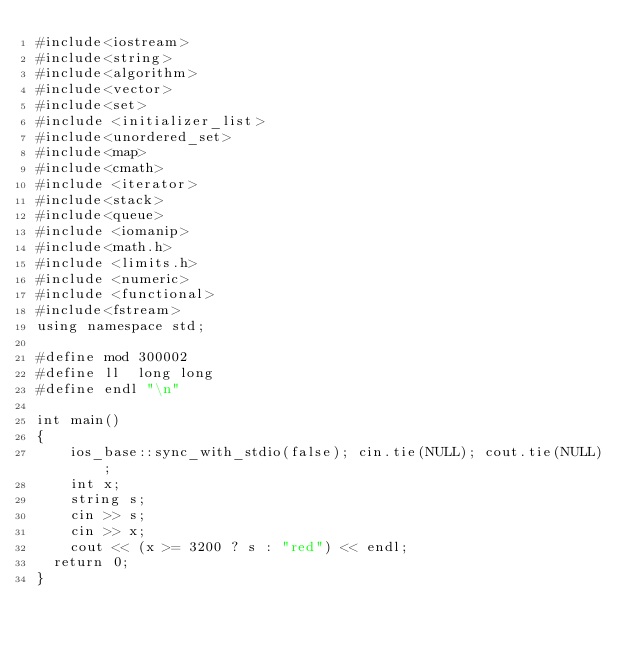Convert code to text. <code><loc_0><loc_0><loc_500><loc_500><_C++_>#include<iostream>
#include<string>
#include<algorithm>
#include<vector>
#include<set>
#include <initializer_list>
#include<unordered_set>
#include<map>
#include<cmath>
#include <iterator>
#include<stack>
#include<queue>
#include <iomanip>
#include<math.h>
#include <limits.h>
#include <numeric>
#include <functional>
#include<fstream>
using namespace std;

#define mod 300002
#define ll  long long
#define endl "\n"

int main()
{
	ios_base::sync_with_stdio(false); cin.tie(NULL); cout.tie(NULL);
	int x;
	string s;
	cin >> s;
	cin >> x;
	cout << (x >= 3200 ? s : "red") << endl;
  return 0;
}</code> 